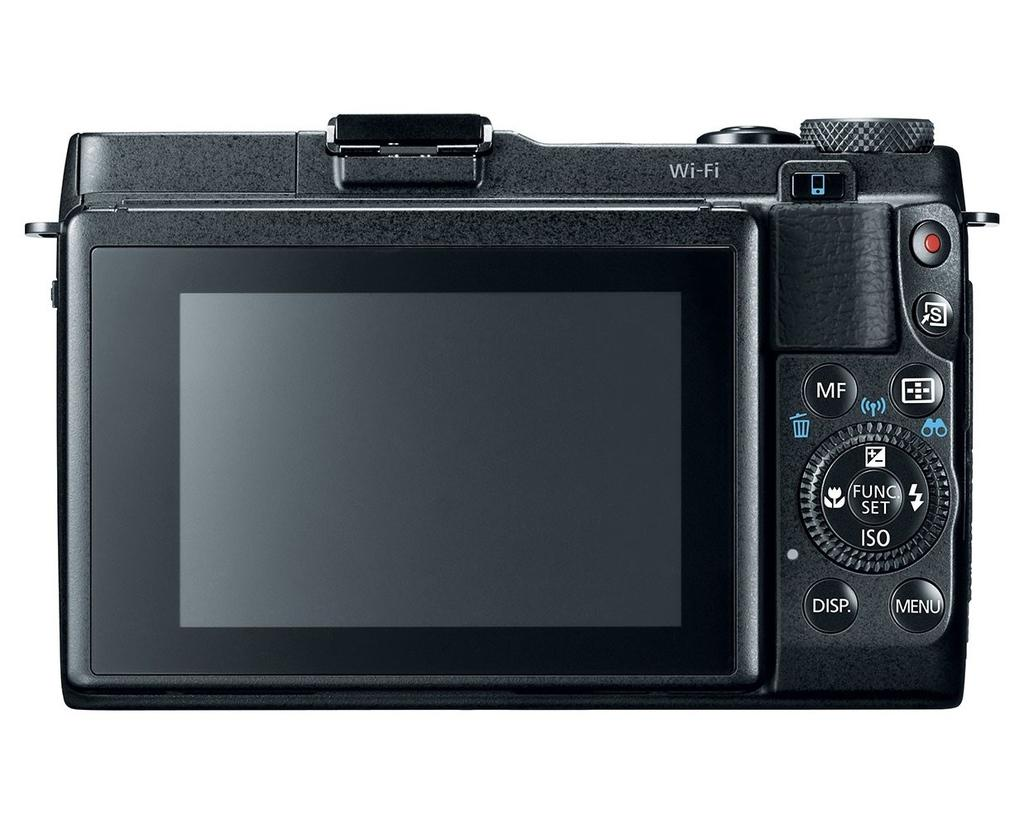What is the main subject of the image? The main subject of the image is a camera. What features does the camera have? The camera has a display screen and buttons. What is the color of the camera? The camera is black in color. What is the background color in the image? The background of the image is white. Can you hear the bell ringing in the image? There is no bell present in the image, so it cannot be heard. What type of drink is being served in the image? There is no drink present in the image, so it cannot be determined. 